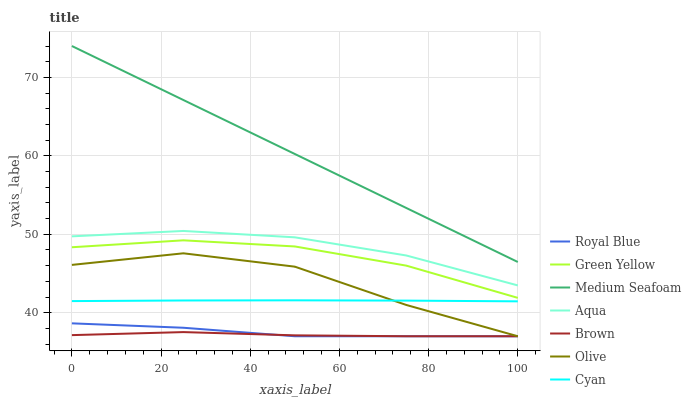Does Aqua have the minimum area under the curve?
Answer yes or no. No. Does Aqua have the maximum area under the curve?
Answer yes or no. No. Is Aqua the smoothest?
Answer yes or no. No. Is Aqua the roughest?
Answer yes or no. No. Does Aqua have the lowest value?
Answer yes or no. No. Does Aqua have the highest value?
Answer yes or no. No. Is Royal Blue less than Cyan?
Answer yes or no. Yes. Is Aqua greater than Cyan?
Answer yes or no. Yes. Does Royal Blue intersect Cyan?
Answer yes or no. No. 